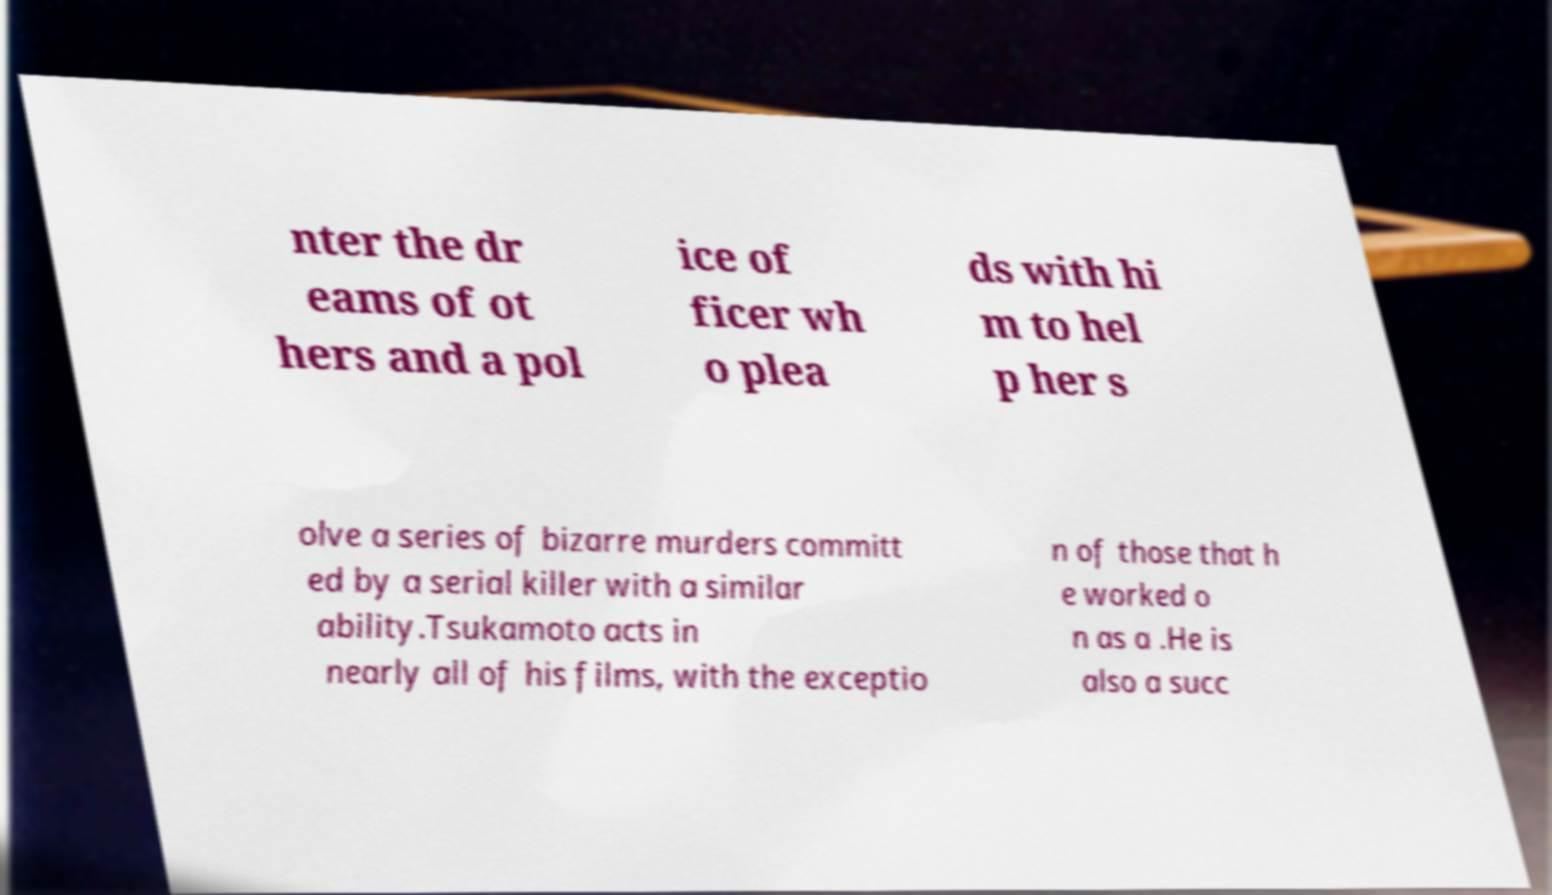What messages or text are displayed in this image? I need them in a readable, typed format. nter the dr eams of ot hers and a pol ice of ficer wh o plea ds with hi m to hel p her s olve a series of bizarre murders committ ed by a serial killer with a similar ability.Tsukamoto acts in nearly all of his films, with the exceptio n of those that h e worked o n as a .He is also a succ 